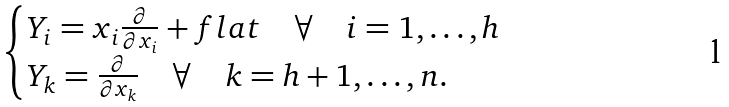<formula> <loc_0><loc_0><loc_500><loc_500>\begin{cases} Y _ { i } = x _ { i } \frac { \partial } { \partial x _ { i } } + f l a t \quad \forall \quad i = 1 , \hdots , h \\ Y _ { k } = \frac { \partial } { \partial x _ { k } } \quad \forall \quad k = h + 1 , \hdots , n . \end{cases}</formula> 